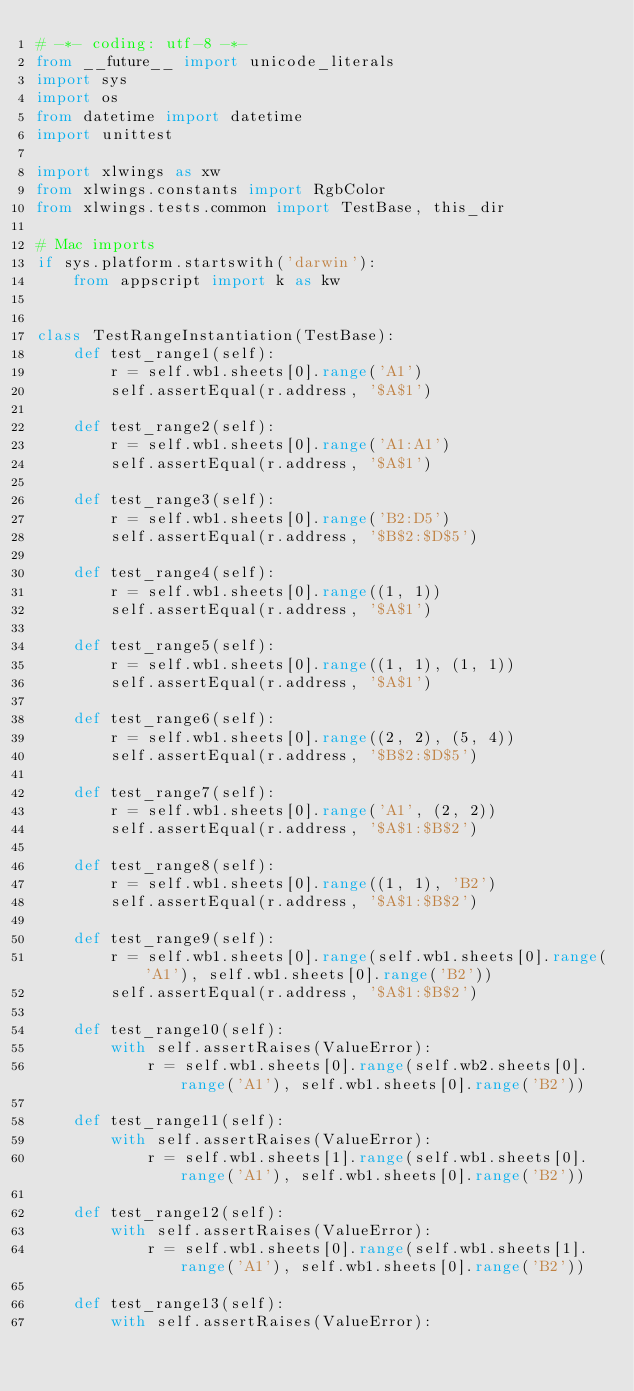<code> <loc_0><loc_0><loc_500><loc_500><_Python_># -*- coding: utf-8 -*-
from __future__ import unicode_literals
import sys
import os
from datetime import datetime
import unittest

import xlwings as xw
from xlwings.constants import RgbColor
from xlwings.tests.common import TestBase, this_dir

# Mac imports
if sys.platform.startswith('darwin'):
    from appscript import k as kw


class TestRangeInstantiation(TestBase):
    def test_range1(self):
        r = self.wb1.sheets[0].range('A1')
        self.assertEqual(r.address, '$A$1')

    def test_range2(self):
        r = self.wb1.sheets[0].range('A1:A1')
        self.assertEqual(r.address, '$A$1')

    def test_range3(self):
        r = self.wb1.sheets[0].range('B2:D5')
        self.assertEqual(r.address, '$B$2:$D$5')

    def test_range4(self):
        r = self.wb1.sheets[0].range((1, 1))
        self.assertEqual(r.address, '$A$1')

    def test_range5(self):
        r = self.wb1.sheets[0].range((1, 1), (1, 1))
        self.assertEqual(r.address, '$A$1')

    def test_range6(self):
        r = self.wb1.sheets[0].range((2, 2), (5, 4))
        self.assertEqual(r.address, '$B$2:$D$5')

    def test_range7(self):
        r = self.wb1.sheets[0].range('A1', (2, 2))
        self.assertEqual(r.address, '$A$1:$B$2')

    def test_range8(self):
        r = self.wb1.sheets[0].range((1, 1), 'B2')
        self.assertEqual(r.address, '$A$1:$B$2')

    def test_range9(self):
        r = self.wb1.sheets[0].range(self.wb1.sheets[0].range('A1'), self.wb1.sheets[0].range('B2'))
        self.assertEqual(r.address, '$A$1:$B$2')

    def test_range10(self):
        with self.assertRaises(ValueError):
            r = self.wb1.sheets[0].range(self.wb2.sheets[0].range('A1'), self.wb1.sheets[0].range('B2'))

    def test_range11(self):
        with self.assertRaises(ValueError):
            r = self.wb1.sheets[1].range(self.wb1.sheets[0].range('A1'), self.wb1.sheets[0].range('B2'))

    def test_range12(self):
        with self.assertRaises(ValueError):
            r = self.wb1.sheets[0].range(self.wb1.sheets[1].range('A1'), self.wb1.sheets[0].range('B2'))

    def test_range13(self):
        with self.assertRaises(ValueError):</code> 